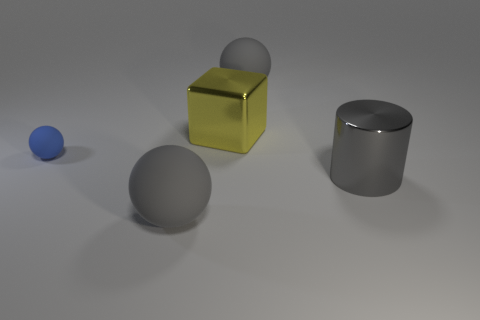Add 5 matte cylinders. How many objects exist? 10 Subtract all spheres. How many objects are left? 2 Subtract 0 cyan cylinders. How many objects are left? 5 Subtract all matte objects. Subtract all metal objects. How many objects are left? 0 Add 1 small blue rubber balls. How many small blue rubber balls are left? 2 Add 3 tiny spheres. How many tiny spheres exist? 4 